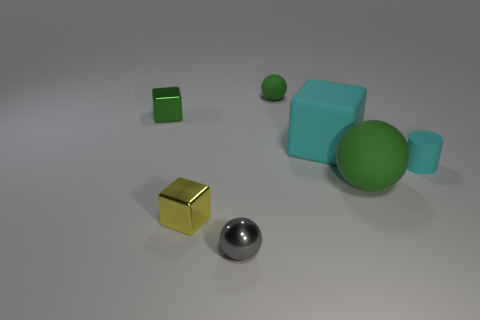Add 2 brown shiny objects. How many objects exist? 9 Subtract all cylinders. How many objects are left? 6 Add 7 green blocks. How many green blocks are left? 8 Add 6 large yellow rubber spheres. How many large yellow rubber spheres exist? 6 Subtract 0 blue balls. How many objects are left? 7 Subtract all red cylinders. Subtract all shiny blocks. How many objects are left? 5 